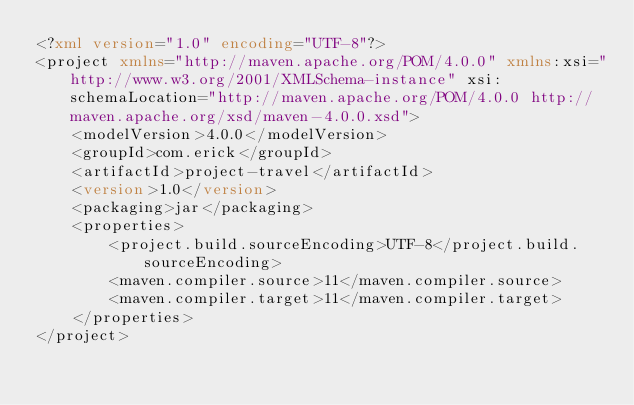<code> <loc_0><loc_0><loc_500><loc_500><_XML_><?xml version="1.0" encoding="UTF-8"?>
<project xmlns="http://maven.apache.org/POM/4.0.0" xmlns:xsi="http://www.w3.org/2001/XMLSchema-instance" xsi:schemaLocation="http://maven.apache.org/POM/4.0.0 http://maven.apache.org/xsd/maven-4.0.0.xsd">
    <modelVersion>4.0.0</modelVersion>
    <groupId>com.erick</groupId>
    <artifactId>project-travel</artifactId>
    <version>1.0</version>
    <packaging>jar</packaging>
    <properties>
        <project.build.sourceEncoding>UTF-8</project.build.sourceEncoding>
        <maven.compiler.source>11</maven.compiler.source>
        <maven.compiler.target>11</maven.compiler.target>
    </properties>
</project></code> 